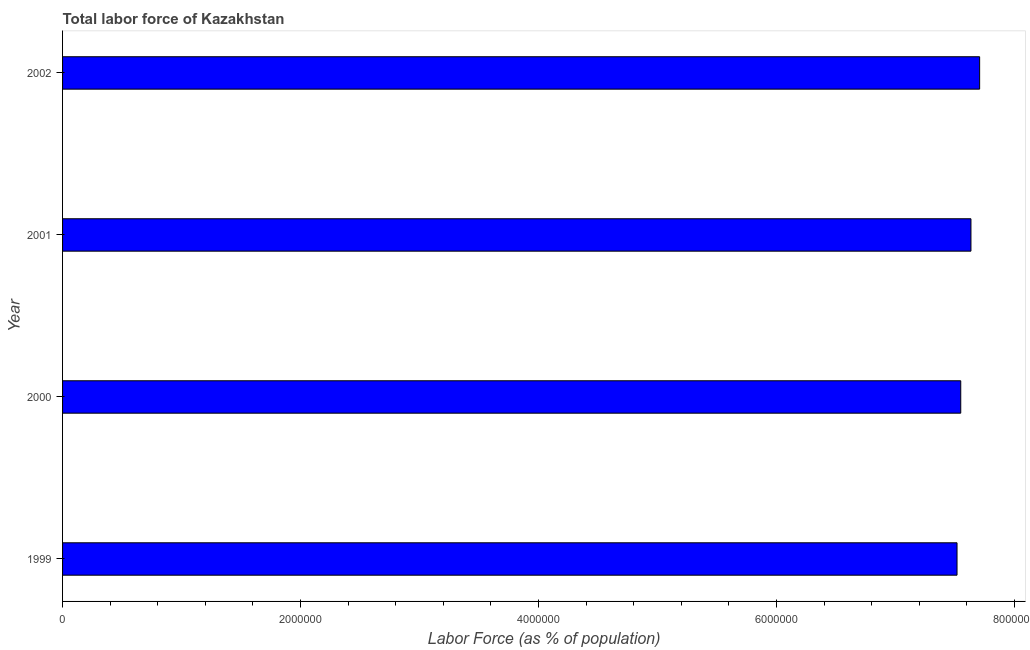Does the graph contain grids?
Give a very brief answer. No. What is the title of the graph?
Provide a short and direct response. Total labor force of Kazakhstan. What is the label or title of the X-axis?
Give a very brief answer. Labor Force (as % of population). What is the total labor force in 1999?
Your answer should be very brief. 7.52e+06. Across all years, what is the maximum total labor force?
Give a very brief answer. 7.71e+06. Across all years, what is the minimum total labor force?
Offer a very short reply. 7.52e+06. In which year was the total labor force minimum?
Your response must be concise. 1999. What is the sum of the total labor force?
Make the answer very short. 3.04e+07. What is the difference between the total labor force in 2000 and 2001?
Give a very brief answer. -8.58e+04. What is the average total labor force per year?
Make the answer very short. 7.60e+06. What is the median total labor force?
Offer a terse response. 7.59e+06. In how many years, is the total labor force greater than 7600000 %?
Give a very brief answer. 2. Do a majority of the years between 2002 and 2000 (inclusive) have total labor force greater than 3600000 %?
Your response must be concise. Yes. Is the difference between the total labor force in 1999 and 2000 greater than the difference between any two years?
Your response must be concise. No. What is the difference between the highest and the second highest total labor force?
Ensure brevity in your answer.  7.29e+04. Is the sum of the total labor force in 2000 and 2001 greater than the maximum total labor force across all years?
Your answer should be very brief. Yes. What is the difference between the highest and the lowest total labor force?
Offer a terse response. 1.90e+05. In how many years, is the total labor force greater than the average total labor force taken over all years?
Offer a very short reply. 2. How many bars are there?
Make the answer very short. 4. Are all the bars in the graph horizontal?
Ensure brevity in your answer.  Yes. How many years are there in the graph?
Your answer should be very brief. 4. What is the difference between two consecutive major ticks on the X-axis?
Your response must be concise. 2.00e+06. Are the values on the major ticks of X-axis written in scientific E-notation?
Provide a short and direct response. No. What is the Labor Force (as % of population) in 1999?
Provide a short and direct response. 7.52e+06. What is the Labor Force (as % of population) in 2000?
Make the answer very short. 7.55e+06. What is the Labor Force (as % of population) in 2001?
Offer a terse response. 7.64e+06. What is the Labor Force (as % of population) of 2002?
Keep it short and to the point. 7.71e+06. What is the difference between the Labor Force (as % of population) in 1999 and 2000?
Offer a very short reply. -3.13e+04. What is the difference between the Labor Force (as % of population) in 1999 and 2001?
Give a very brief answer. -1.17e+05. What is the difference between the Labor Force (as % of population) in 1999 and 2002?
Provide a succinct answer. -1.90e+05. What is the difference between the Labor Force (as % of population) in 2000 and 2001?
Give a very brief answer. -8.58e+04. What is the difference between the Labor Force (as % of population) in 2000 and 2002?
Your answer should be compact. -1.59e+05. What is the difference between the Labor Force (as % of population) in 2001 and 2002?
Provide a succinct answer. -7.29e+04. What is the ratio of the Labor Force (as % of population) in 1999 to that in 2000?
Provide a succinct answer. 1. What is the ratio of the Labor Force (as % of population) in 1999 to that in 2002?
Keep it short and to the point. 0.97. What is the ratio of the Labor Force (as % of population) in 2000 to that in 2001?
Offer a very short reply. 0.99. What is the ratio of the Labor Force (as % of population) in 2000 to that in 2002?
Provide a short and direct response. 0.98. What is the ratio of the Labor Force (as % of population) in 2001 to that in 2002?
Offer a terse response. 0.99. 